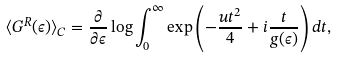Convert formula to latex. <formula><loc_0><loc_0><loc_500><loc_500>\langle G ^ { R } ( \epsilon ) \rangle _ { C } = \frac { \partial } { \partial \epsilon } \log \int _ { 0 } ^ { \infty } \exp \left ( - \frac { u t ^ { 2 } } { 4 } + i \frac { t } { g ( \epsilon ) } \right ) d t ,</formula> 